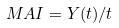Convert formula to latex. <formula><loc_0><loc_0><loc_500><loc_500>M A I = Y ( t ) / t</formula> 